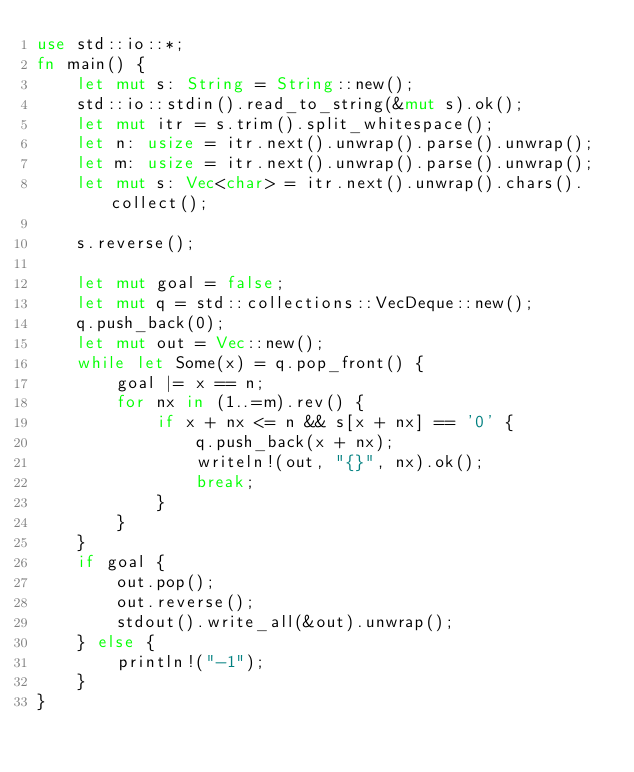<code> <loc_0><loc_0><loc_500><loc_500><_Rust_>use std::io::*;
fn main() {
    let mut s: String = String::new();
    std::io::stdin().read_to_string(&mut s).ok();
    let mut itr = s.trim().split_whitespace();
    let n: usize = itr.next().unwrap().parse().unwrap();
    let m: usize = itr.next().unwrap().parse().unwrap();
    let mut s: Vec<char> = itr.next().unwrap().chars().collect();

    s.reverse();

    let mut goal = false;
    let mut q = std::collections::VecDeque::new();
    q.push_back(0);
    let mut out = Vec::new();
    while let Some(x) = q.pop_front() {
        goal |= x == n;
        for nx in (1..=m).rev() {
            if x + nx <= n && s[x + nx] == '0' {
                q.push_back(x + nx);
                writeln!(out, "{}", nx).ok();
                break;
            }
        }
    }
    if goal {
        out.pop();
        out.reverse();
        stdout().write_all(&out).unwrap();
    } else {
        println!("-1");
    }
}
</code> 